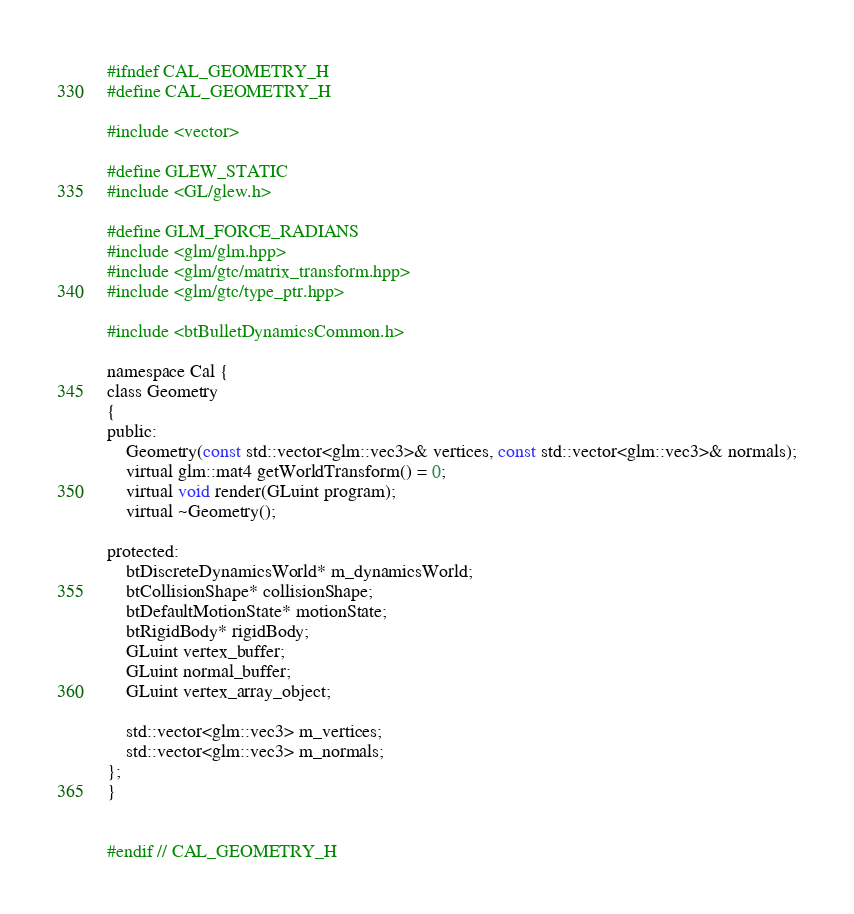Convert code to text. <code><loc_0><loc_0><loc_500><loc_500><_C_>#ifndef CAL_GEOMETRY_H
#define CAL_GEOMETRY_H

#include <vector>

#define GLEW_STATIC
#include <GL/glew.h>

#define GLM_FORCE_RADIANS
#include <glm/glm.hpp>
#include <glm/gtc/matrix_transform.hpp>
#include <glm/gtc/type_ptr.hpp>

#include <btBulletDynamicsCommon.h>

namespace Cal {
class Geometry
{
public:
    Geometry(const std::vector<glm::vec3>& vertices, const std::vector<glm::vec3>& normals);
    virtual glm::mat4 getWorldTransform() = 0;
    virtual void render(GLuint program);
    virtual ~Geometry();

protected:
    btDiscreteDynamicsWorld* m_dynamicsWorld;
    btCollisionShape* collisionShape;
    btDefaultMotionState* motionState;
    btRigidBody* rigidBody;
    GLuint vertex_buffer;
    GLuint normal_buffer;
    GLuint vertex_array_object;

    std::vector<glm::vec3> m_vertices;
    std::vector<glm::vec3> m_normals;
};
}


#endif // CAL_GEOMETRY_H
</code> 